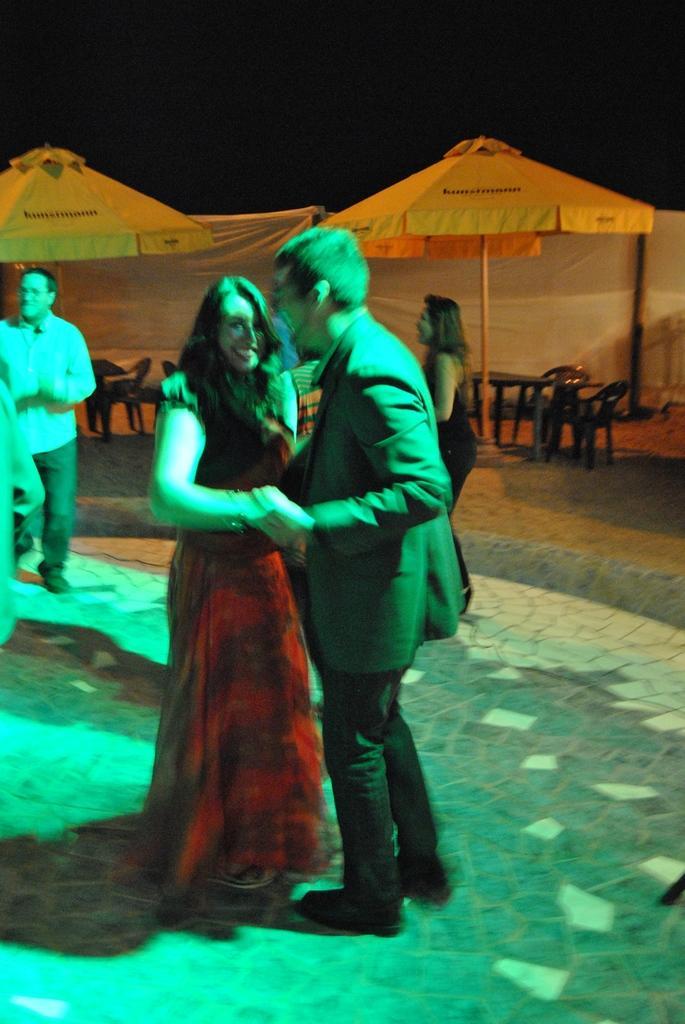Please provide a concise description of this image. In this image, we can see a couple dancing, in the background, we can see some people standing and we can see two umbrellas. 